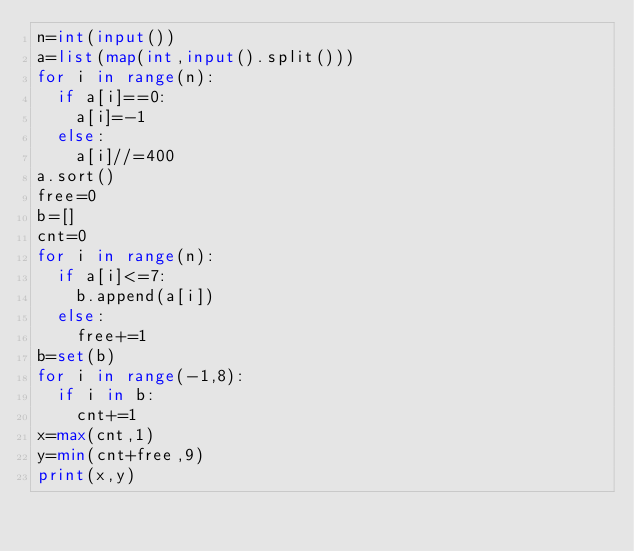<code> <loc_0><loc_0><loc_500><loc_500><_Python_>n=int(input())
a=list(map(int,input().split()))
for i in range(n):
	if a[i]==0:
		a[i]=-1
	else:
		a[i]//=400
a.sort()
free=0
b=[]
cnt=0
for i in range(n):
	if a[i]<=7:
		b.append(a[i])
	else:
		free+=1
b=set(b)
for i in range(-1,8):
	if i in b:
		cnt+=1
x=max(cnt,1)
y=min(cnt+free,9)
print(x,y)</code> 